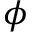Convert formula to latex. <formula><loc_0><loc_0><loc_500><loc_500>\phi</formula> 